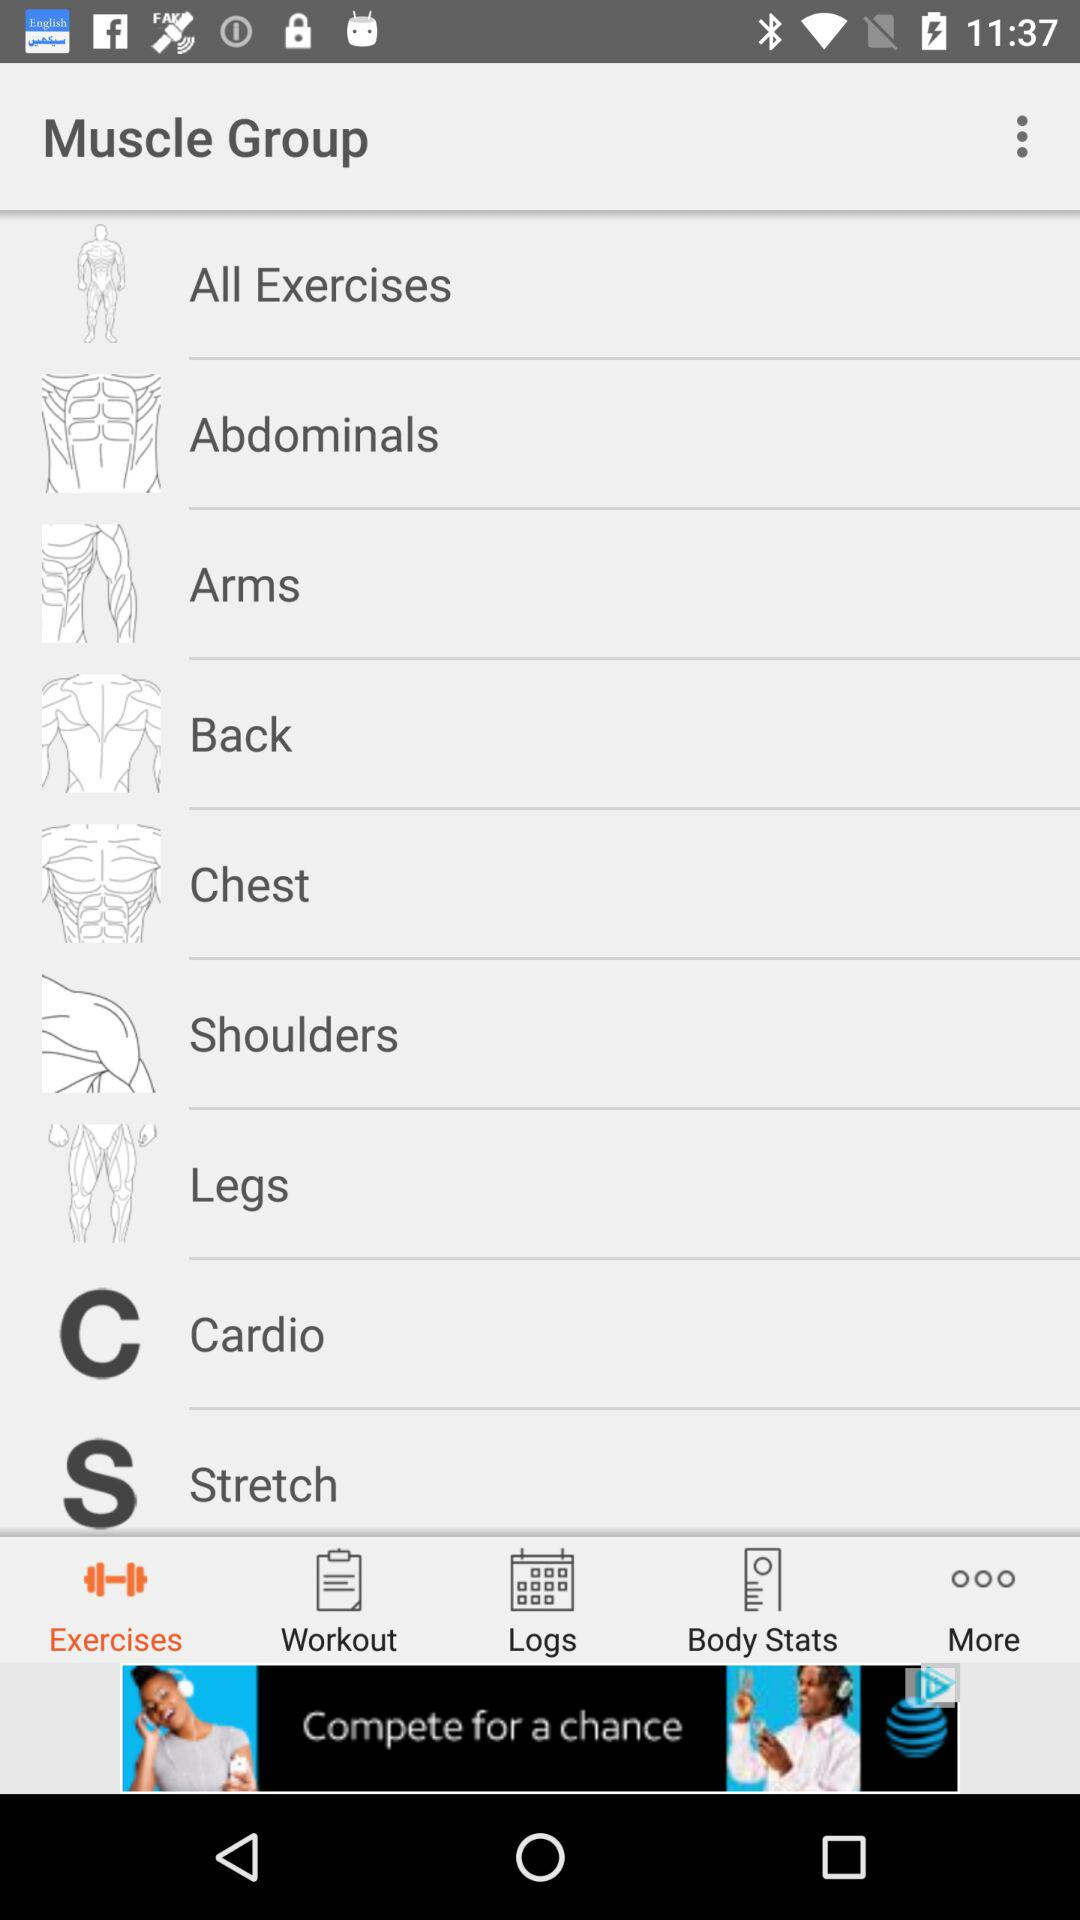Which option has been selected? The selected option is "Exercises". 